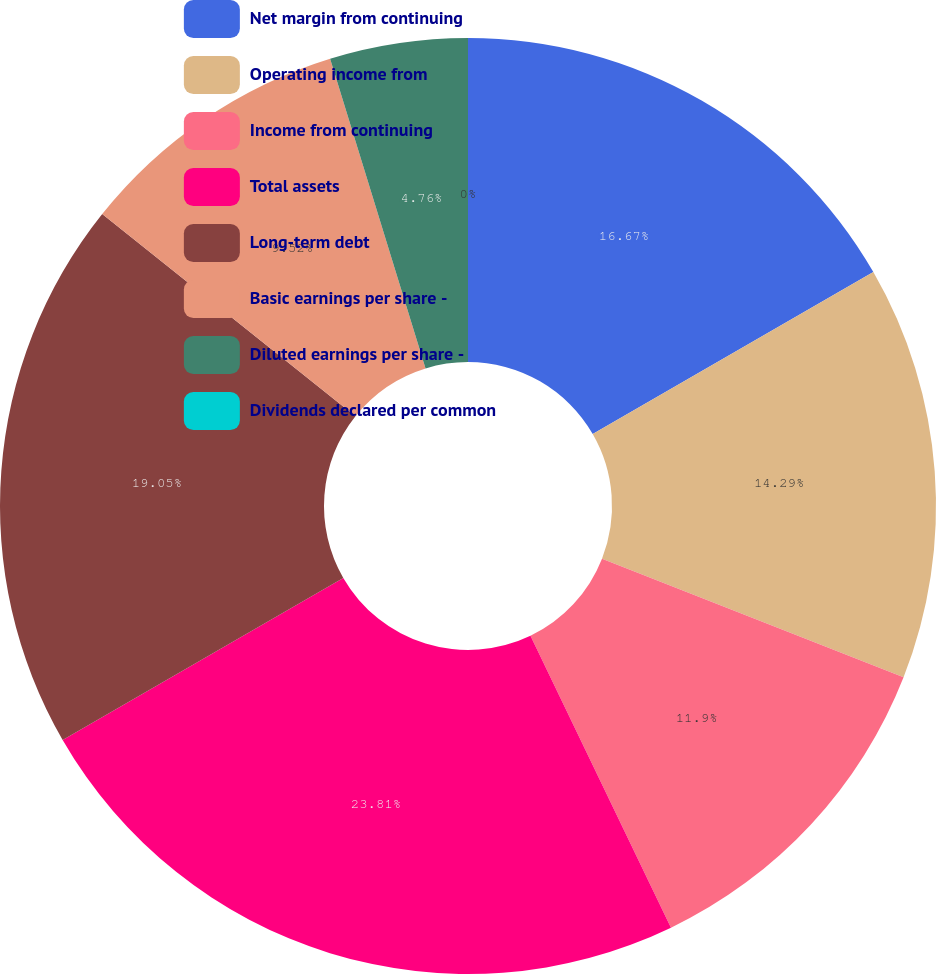<chart> <loc_0><loc_0><loc_500><loc_500><pie_chart><fcel>Net margin from continuing<fcel>Operating income from<fcel>Income from continuing<fcel>Total assets<fcel>Long-term debt<fcel>Basic earnings per share -<fcel>Diluted earnings per share -<fcel>Dividends declared per common<nl><fcel>16.67%<fcel>14.29%<fcel>11.9%<fcel>23.81%<fcel>19.05%<fcel>9.52%<fcel>4.76%<fcel>0.0%<nl></chart> 